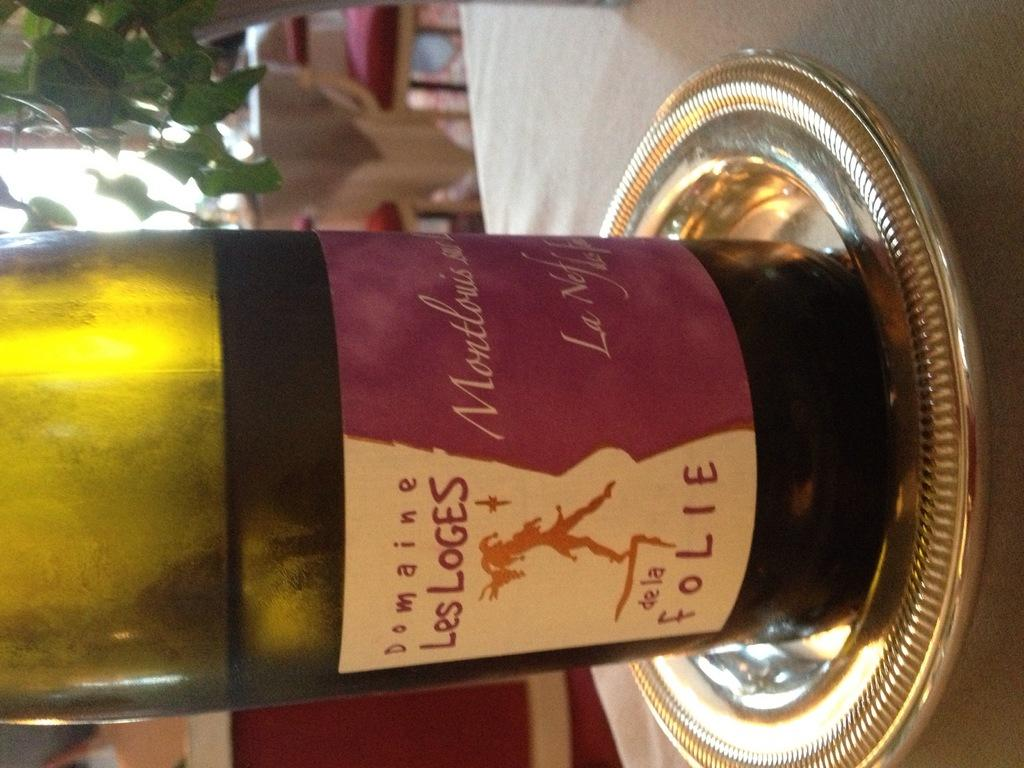Provide a one-sentence caption for the provided image. a bottle of Les Loges that is on a silver plate. 